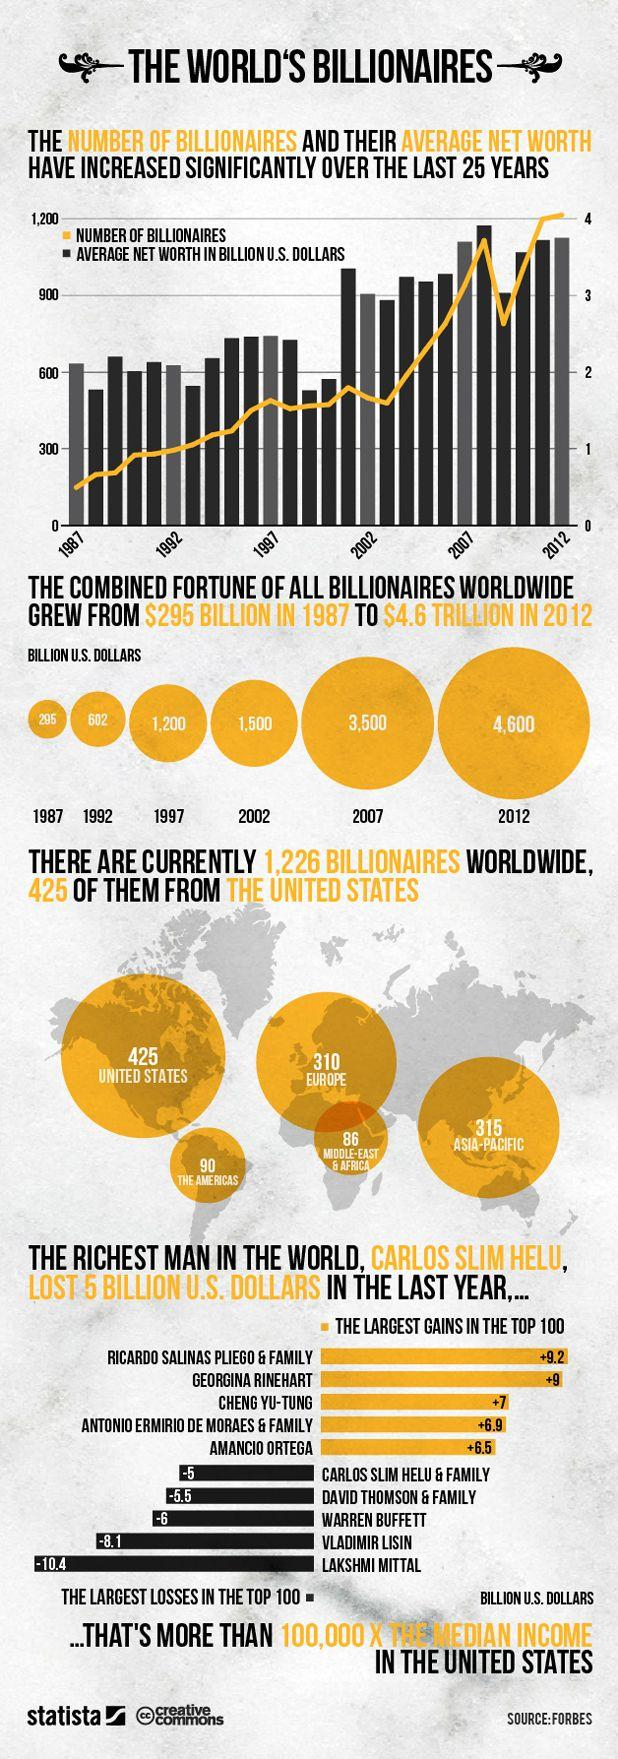Identify some key points in this picture. The number of billionaires in the United States and the Asia-Pacific region taken together is 740. 